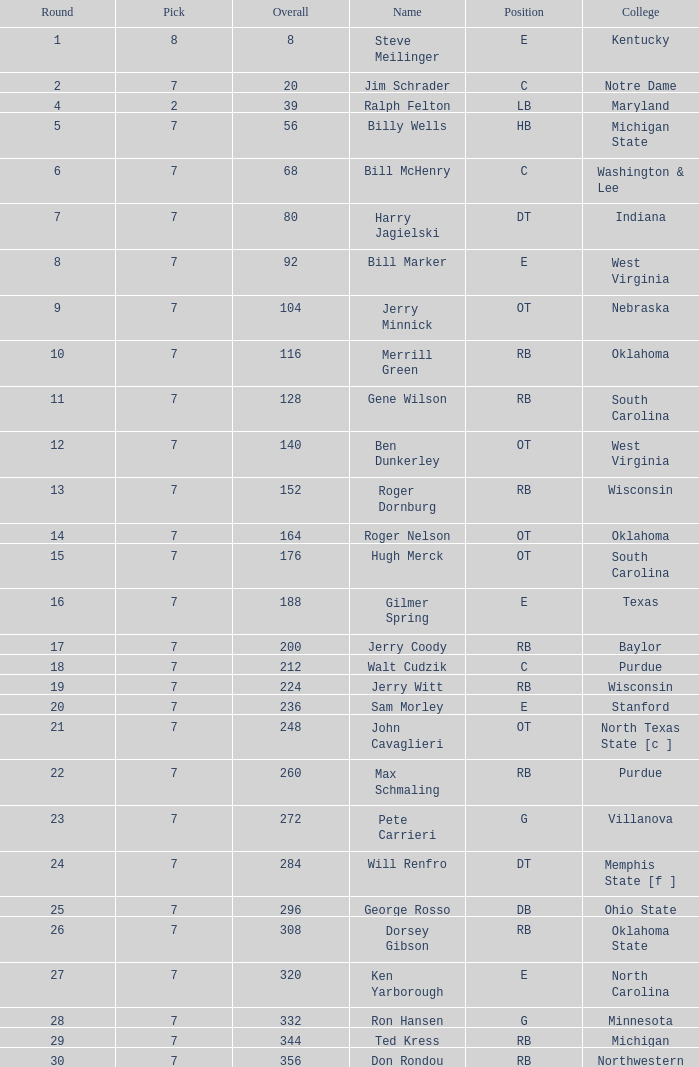What is the number of the round in which Ron Hansen was drafted and the overall is greater than 332? 0.0. 